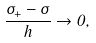<formula> <loc_0><loc_0><loc_500><loc_500>\frac { \sigma _ { + } - \sigma } { h } \to 0 ,</formula> 